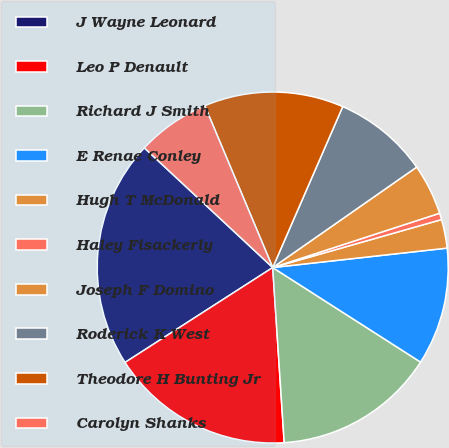Convert chart to OTSL. <chart><loc_0><loc_0><loc_500><loc_500><pie_chart><fcel>J Wayne Leonard<fcel>Leo P Denault<fcel>Richard J Smith<fcel>E Renae Conley<fcel>Hugh T McDonald<fcel>Haley Fisackerly<fcel>Joseph F Domino<fcel>Roderick K West<fcel>Theodore H Bunting Jr<fcel>Carolyn Shanks<nl><fcel>21.03%<fcel>16.95%<fcel>14.9%<fcel>10.82%<fcel>2.64%<fcel>0.6%<fcel>4.69%<fcel>8.77%<fcel>12.86%<fcel>6.73%<nl></chart> 